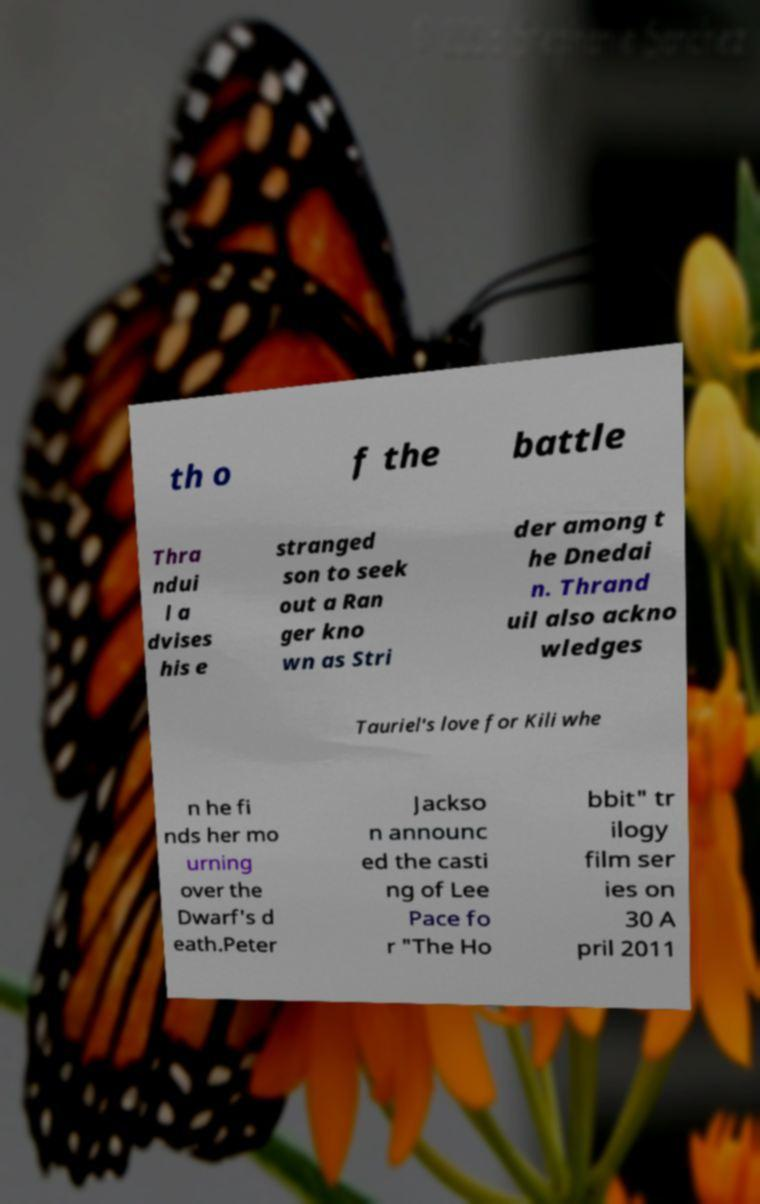Can you read and provide the text displayed in the image?This photo seems to have some interesting text. Can you extract and type it out for me? th o f the battle Thra ndui l a dvises his e stranged son to seek out a Ran ger kno wn as Stri der among t he Dnedai n. Thrand uil also ackno wledges Tauriel's love for Kili whe n he fi nds her mo urning over the Dwarf's d eath.Peter Jackso n announc ed the casti ng of Lee Pace fo r "The Ho bbit" tr ilogy film ser ies on 30 A pril 2011 